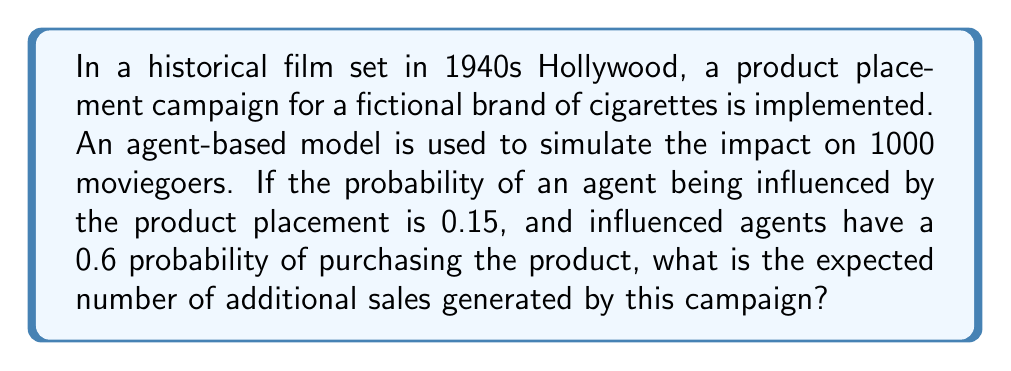Give your solution to this math problem. Let's approach this step-by-step:

1) First, we need to calculate the number of moviegoers influenced by the product placement:
   - Total number of agents (moviegoers) = 1000
   - Probability of being influenced = 0.15
   - Expected number of influenced agents = $1000 \times 0.15 = 150$

2) Next, we calculate the number of influenced agents who are expected to make a purchase:
   - Number of influenced agents = 150
   - Probability of purchasing = 0.6
   - Expected number of purchases = $150 \times 0.6 = 90$

3) Therefore, the expected number of additional sales generated by this campaign is 90.

This can be expressed in a single formula:

$$ E(\text{sales}) = N \times P(\text{influenced}) \times P(\text{purchase | influenced}) $$

Where:
$E(\text{sales})$ is the expected number of sales
$N$ is the total number of agents
$P(\text{influenced})$ is the probability of being influenced
$P(\text{purchase | influenced})$ is the probability of purchasing given that an agent is influenced

Plugging in our values:

$$ E(\text{sales}) = 1000 \times 0.15 \times 0.6 = 90 $$
Answer: 90 